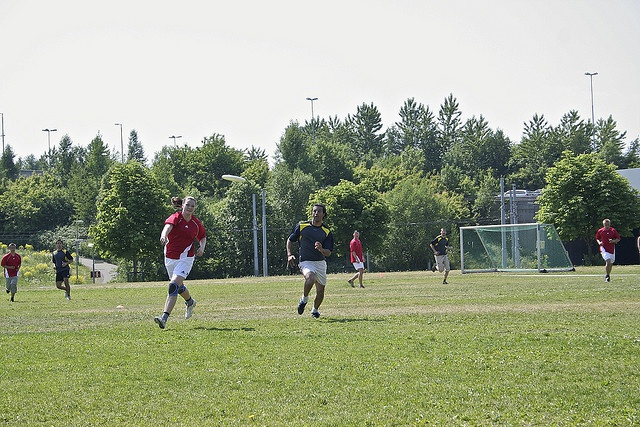Describe the objects in this image and their specific colors. I can see people in white, maroon, gray, black, and darkgray tones, people in white, black, gray, and darkgray tones, people in white, maroon, black, gray, and darkgray tones, people in white, maroon, gray, black, and darkgreen tones, and people in white, black, gray, navy, and darkgreen tones in this image. 